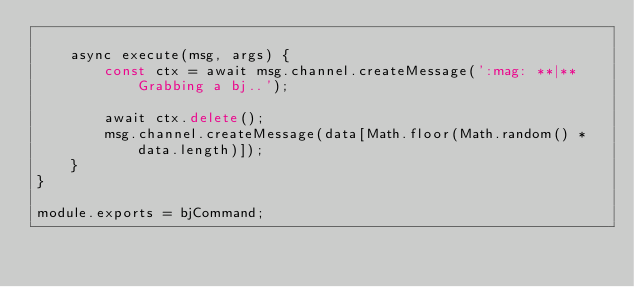Convert code to text. <code><loc_0><loc_0><loc_500><loc_500><_JavaScript_>
    async execute(msg, args) {
        const ctx = await msg.channel.createMessage(':mag: **|** Grabbing a bj..');

        await ctx.delete();
        msg.channel.createMessage(data[Math.floor(Math.random() * data.length)]);
    }
}

module.exports = bjCommand;</code> 